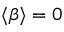Convert formula to latex. <formula><loc_0><loc_0><loc_500><loc_500>\langle \beta \rangle = 0</formula> 